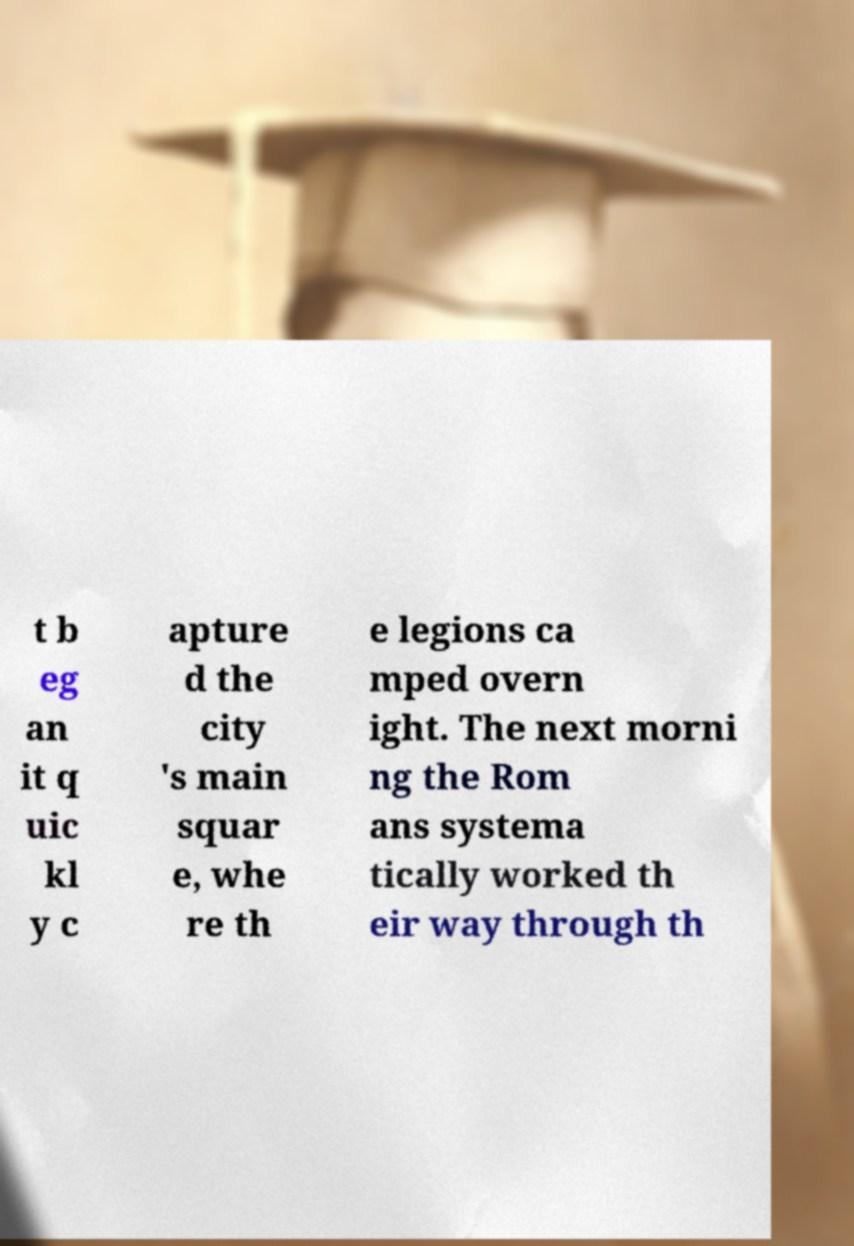Can you read and provide the text displayed in the image?This photo seems to have some interesting text. Can you extract and type it out for me? t b eg an it q uic kl y c apture d the city 's main squar e, whe re th e legions ca mped overn ight. The next morni ng the Rom ans systema tically worked th eir way through th 